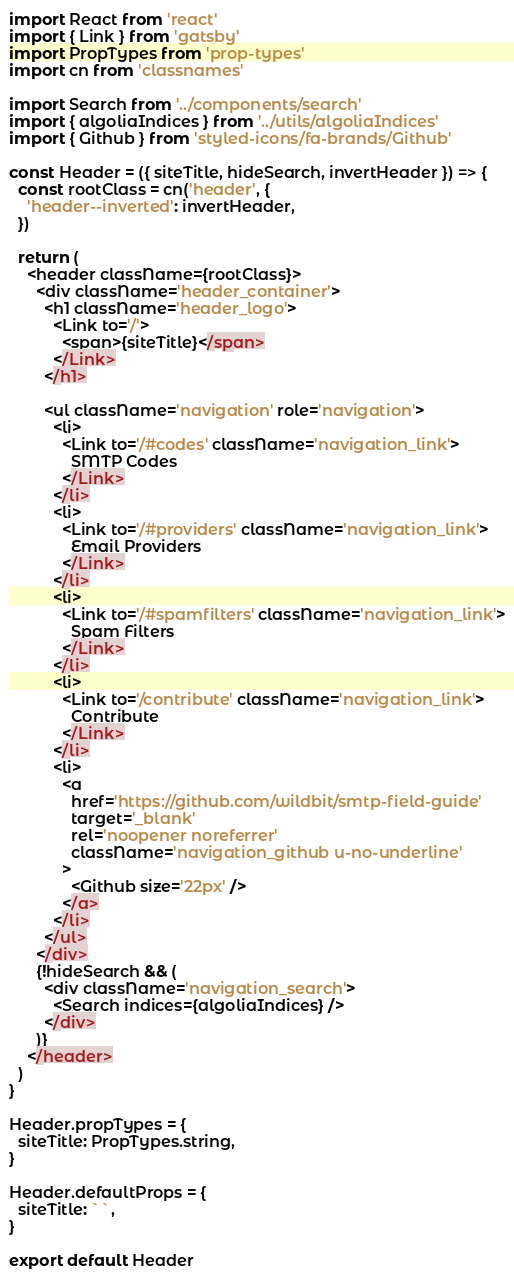<code> <loc_0><loc_0><loc_500><loc_500><_JavaScript_>import React from 'react'
import { Link } from 'gatsby'
import PropTypes from 'prop-types'
import cn from 'classnames'

import Search from '../components/search'
import { algoliaIndices } from '../utils/algoliaIndices'
import { Github } from 'styled-icons/fa-brands/Github'

const Header = ({ siteTitle, hideSearch, invertHeader }) => {
  const rootClass = cn('header', {
    'header--inverted': invertHeader,
  })

  return (
    <header className={rootClass}>
      <div className='header_container'>
        <h1 className='header_logo'>
          <Link to='/'>
            <span>{siteTitle}</span>
          </Link>
        </h1>

        <ul className='navigation' role='navigation'>
          <li>
            <Link to='/#codes' className='navigation_link'>
              SMTP Codes
            </Link>
          </li>
          <li>
            <Link to='/#providers' className='navigation_link'>
              Email Providers
            </Link>
          </li>
          <li>
            <Link to='/#spamfilters' className='navigation_link'>
              Spam Filters
            </Link>
          </li>
          <li>
            <Link to='/contribute' className='navigation_link'>
              Contribute
            </Link>
          </li>
          <li>
            <a
              href='https://github.com/wildbit/smtp-field-guide'
              target='_blank'
              rel='noopener noreferrer'
              className='navigation_github u-no-underline'
            >
              <Github size='22px' />
            </a>
          </li>
        </ul>
      </div>
      {!hideSearch && (
        <div className='navigation_search'>
          <Search indices={algoliaIndices} />
        </div>
      )}
    </header>
  )
}

Header.propTypes = {
  siteTitle: PropTypes.string,
}

Header.defaultProps = {
  siteTitle: ``,
}

export default Header
</code> 